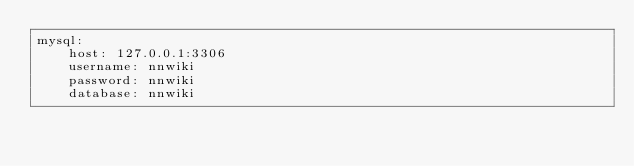<code> <loc_0><loc_0><loc_500><loc_500><_YAML_>mysql:
    host: 127.0.0.1:3306
    username: nnwiki
    password: nnwiki
    database: nnwiki
</code> 